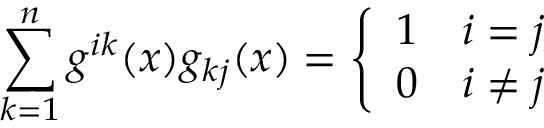<formula> <loc_0><loc_0><loc_500><loc_500>\sum _ { k = 1 } ^ { n } g ^ { i k } ( x ) g _ { k j } ( x ) = { \left \{ \begin{array} { l l } { 1 } & { i = j } \\ { 0 } & { i \neq j } \end{array} }</formula> 